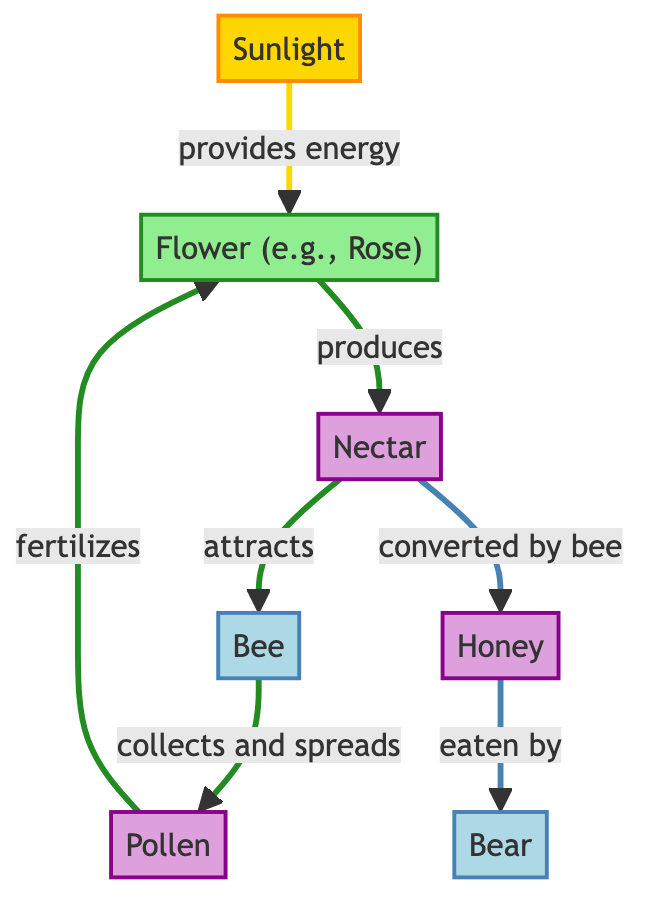What is the first node in the flow of the diagram? The first node in the flow is 'Sunlight', which provides energy to the flower, initiated by the arrow connected to it.
Answer: Sunlight How many animal nodes are present in the diagram? The diagram displays two animal nodes: 'Bee' and 'Bear', as evidenced by their distinct labels in the flow.
Answer: 2 What does the flower produce? The flower produces 'Nectar', which is indicated as the next element in the flow after the flower node.
Answer: Nectar Which product is consumed by the bear? The product eaten by the bear is 'Honey', as shown in the flow from 'Honey' to the 'Bear' node.
Answer: Honey What role does the bee play in the ecosystem described? The bee 'collects and spreads' pollen, demonstrated by the description of its interaction with the pollen node in the diagram.
Answer: Collects and spreads pollen If the flower is fertilized by pollen, what is the source of that pollen? The source of the pollen is from the bee, which collects it and then spreads it to fertilize the flower, as depicted in the flow of the diagram connecting these two elements.
Answer: Bee What is the direct relationship between nectar and honey? Nectar is 'converted by' the bee into honey, therefore it serves as the primary source for honey production in the diagram.
Answer: Converted by bee In terms of energy flow, which element provides energy to the flower? The energy source for the flower is 'Sunlight', which is explicitly connected to the flower in the flow diagram.
Answer: Sunlight Describe the second step in the food chain process. The second step involves the flower producing nectar after receiving energy from sunlight, leading to the next interaction with the bee.
Answer: Flower produces nectar 